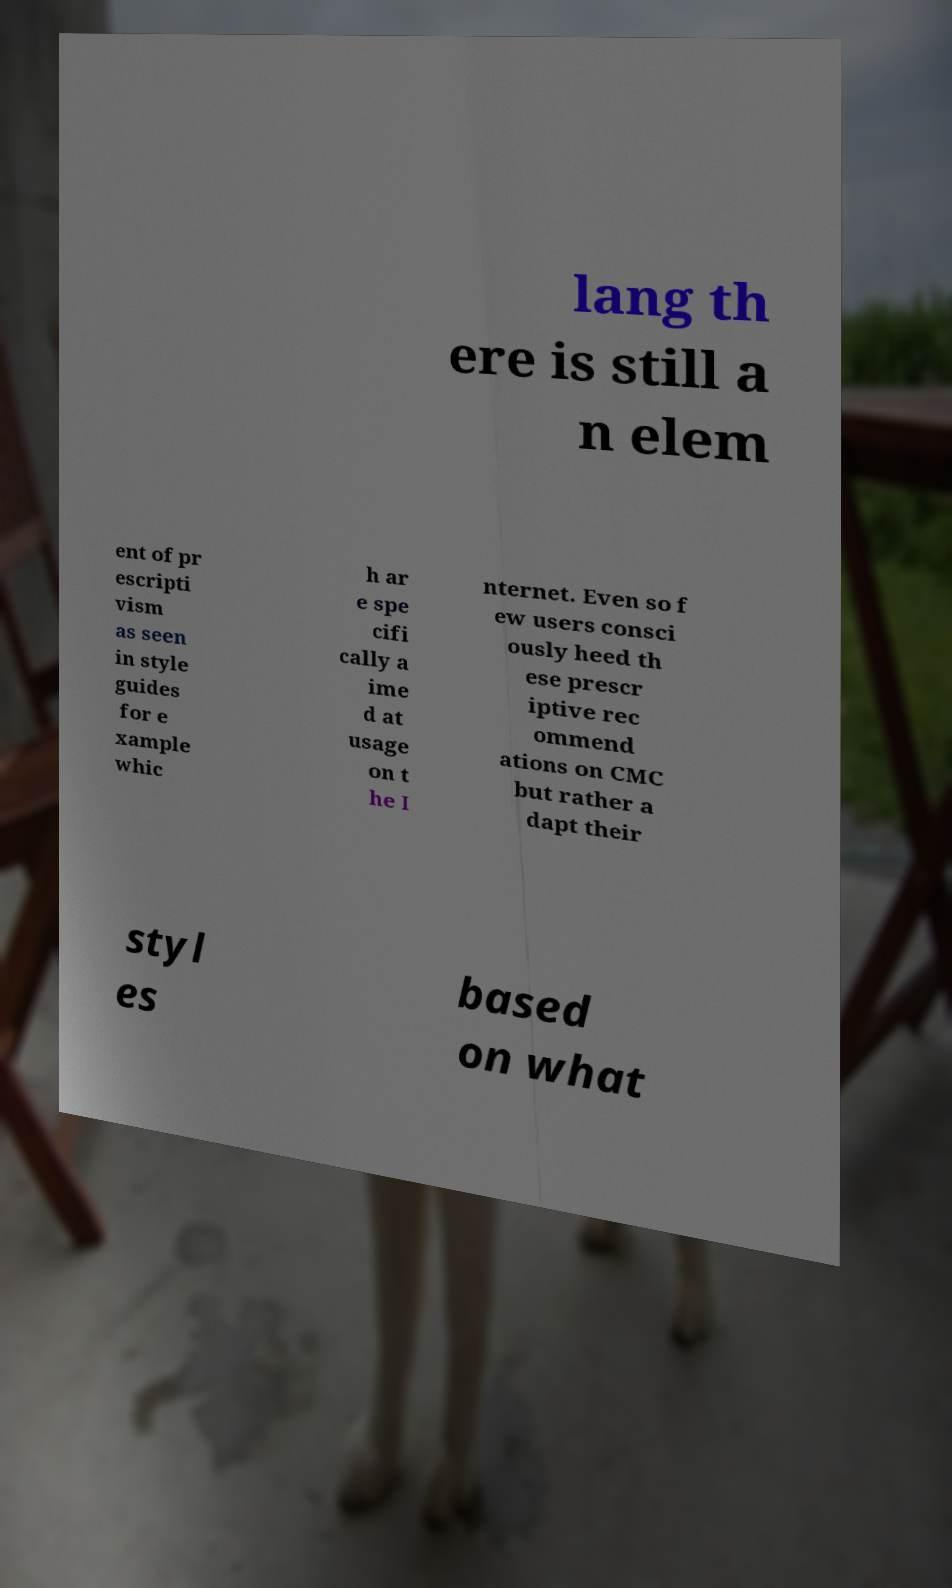Can you accurately transcribe the text from the provided image for me? lang th ere is still a n elem ent of pr escripti vism as seen in style guides for e xample whic h ar e spe cifi cally a ime d at usage on t he I nternet. Even so f ew users consci ously heed th ese prescr iptive rec ommend ations on CMC but rather a dapt their styl es based on what 